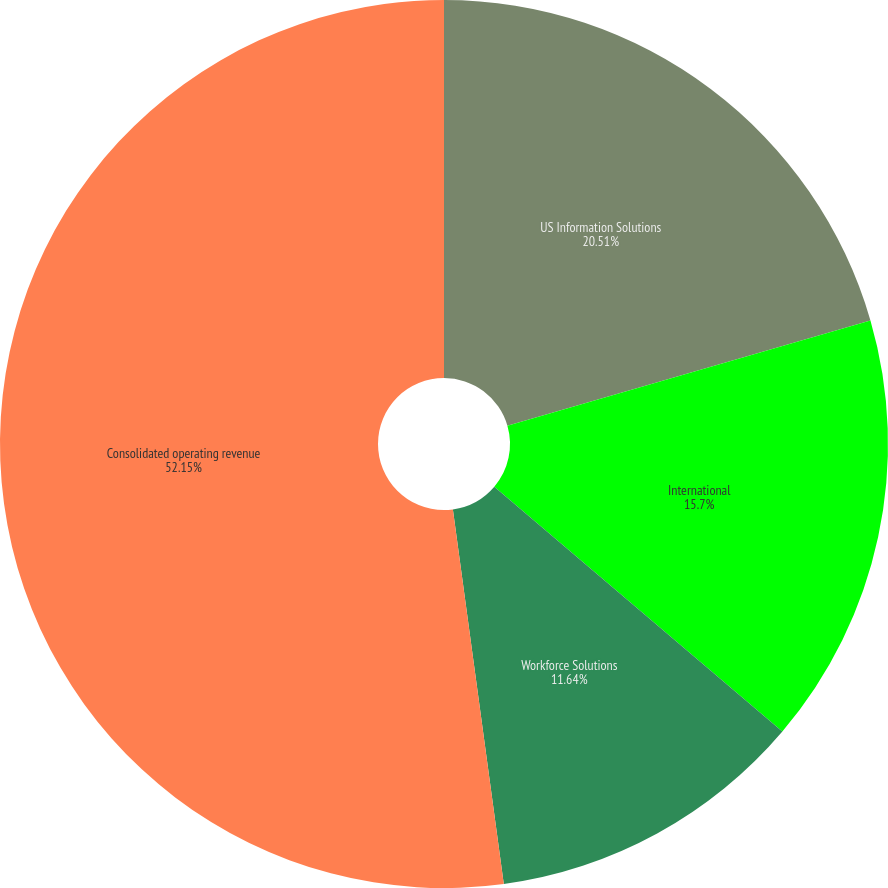Convert chart to OTSL. <chart><loc_0><loc_0><loc_500><loc_500><pie_chart><fcel>US Information Solutions<fcel>International<fcel>Workforce Solutions<fcel>Consolidated operating revenue<nl><fcel>20.51%<fcel>15.7%<fcel>11.64%<fcel>52.15%<nl></chart> 